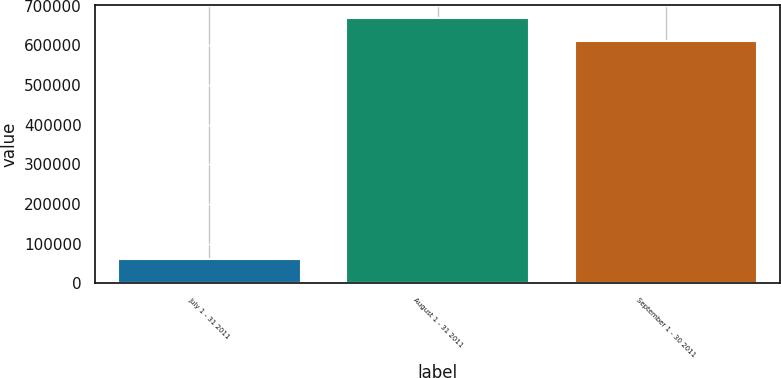<chart> <loc_0><loc_0><loc_500><loc_500><bar_chart><fcel>July 1 - 31 2011<fcel>August 1 - 31 2011<fcel>September 1 - 30 2011<nl><fcel>60000<fcel>668348<fcel>611319<nl></chart> 